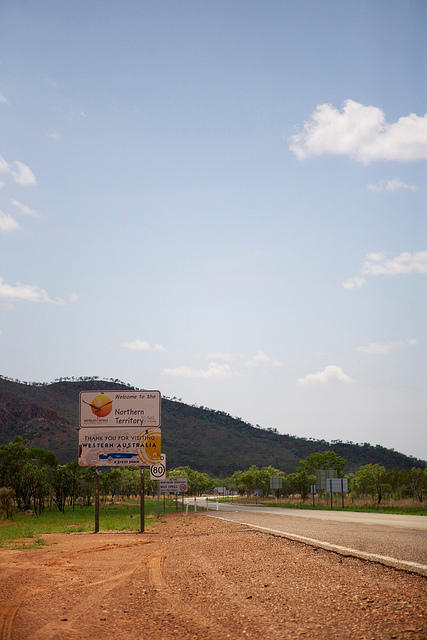<image>What highway is the sign pointing towards? It is unknown what highway the sign is pointing towards. The sign may be pointing towards 'highway 109', 'north highway', or '80'. What highway is the sign pointing towards? I don't know what highway the sign is pointing towards. It could be 'australia', 'highway 109', '1 on right', 'north highway', '80', 'that 1', 'road ahead', 'town', or '1 on right'. 